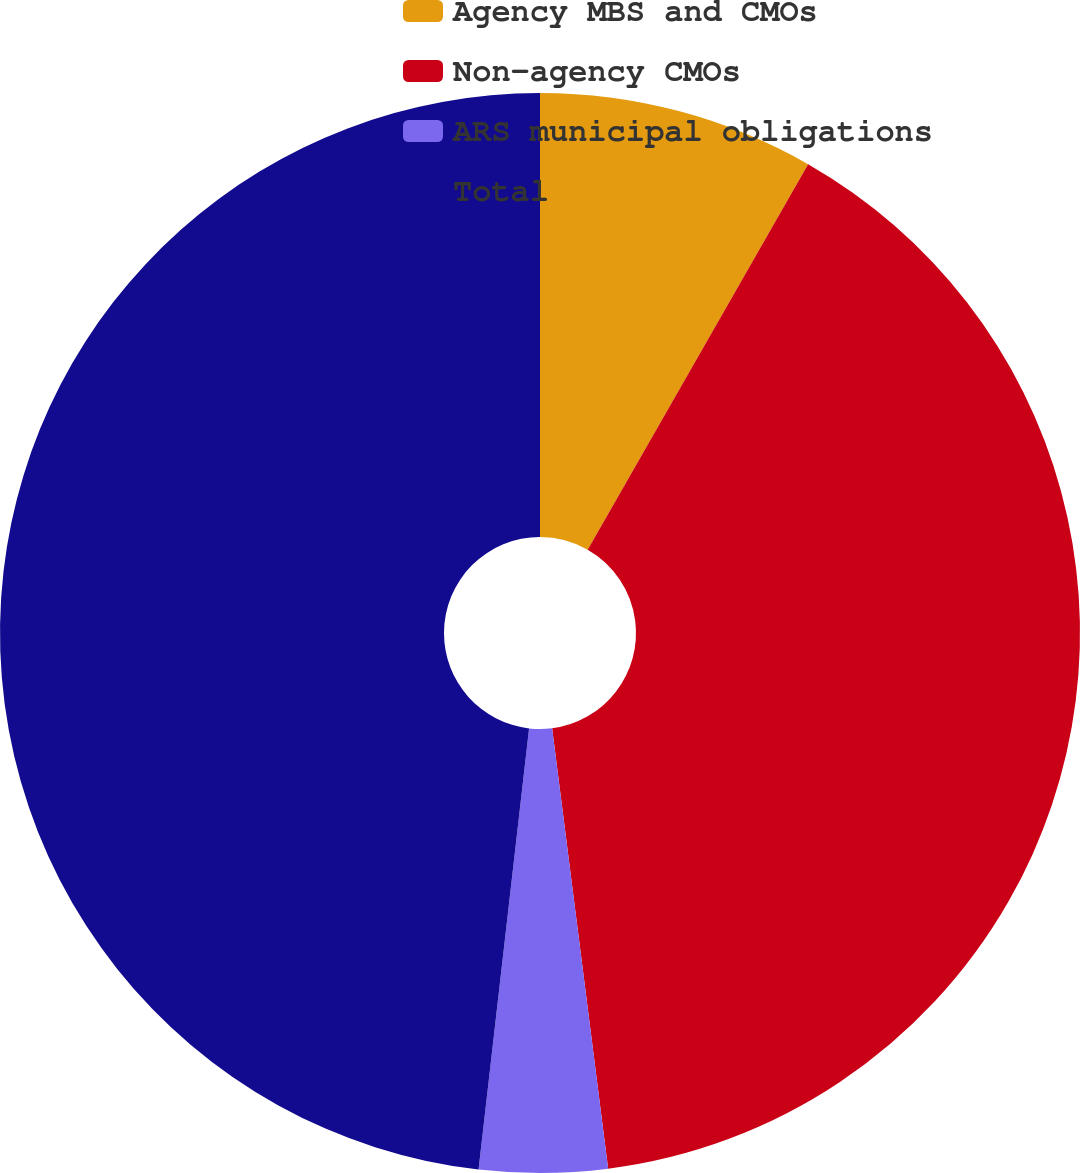Convert chart. <chart><loc_0><loc_0><loc_500><loc_500><pie_chart><fcel>Agency MBS and CMOs<fcel>Non-agency CMOs<fcel>ARS municipal obligations<fcel>Total<nl><fcel>8.27%<fcel>39.72%<fcel>3.83%<fcel>48.19%<nl></chart> 